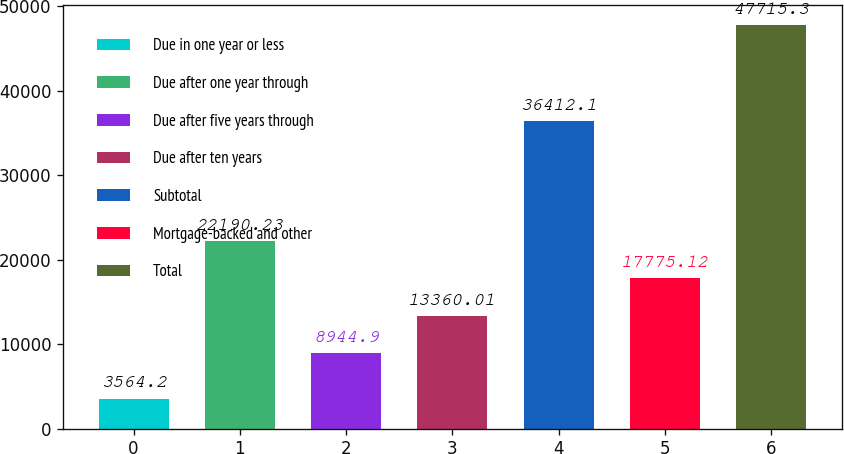Convert chart to OTSL. <chart><loc_0><loc_0><loc_500><loc_500><bar_chart><fcel>Due in one year or less<fcel>Due after one year through<fcel>Due after five years through<fcel>Due after ten years<fcel>Subtotal<fcel>Mortgage-backed and other<fcel>Total<nl><fcel>3564.2<fcel>22190.2<fcel>8944.9<fcel>13360<fcel>36412.1<fcel>17775.1<fcel>47715.3<nl></chart> 